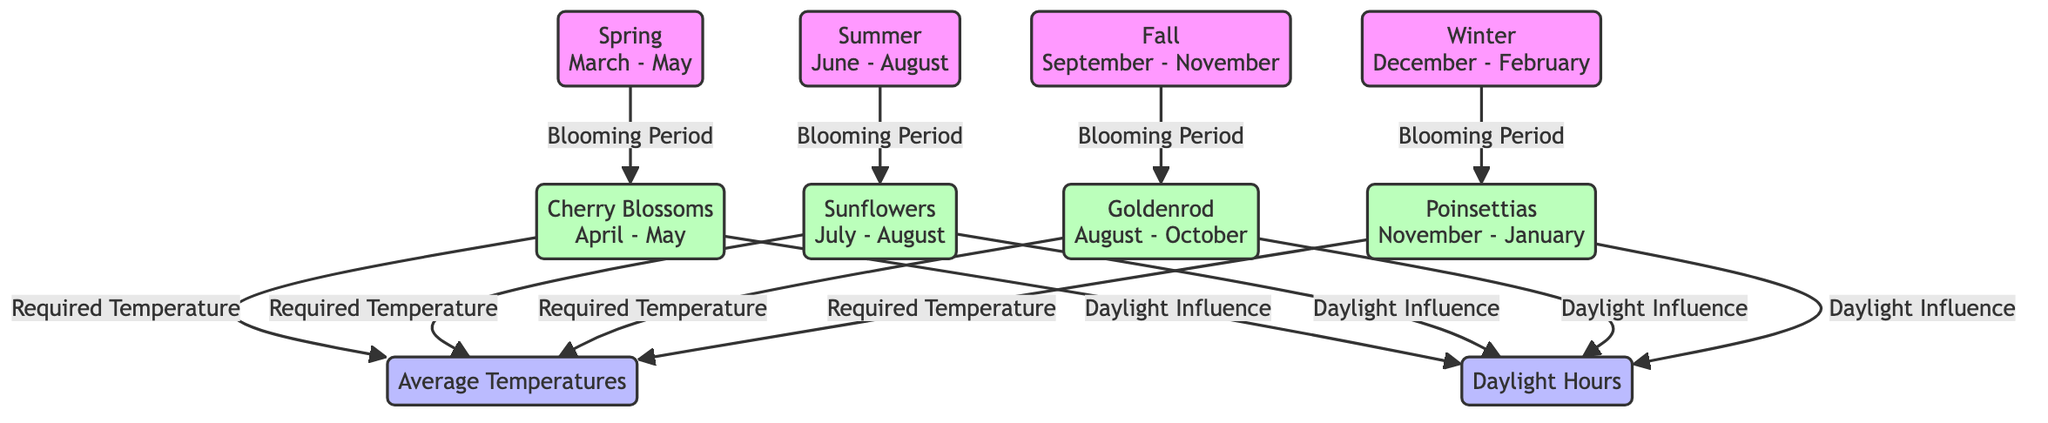What is the blooming period for Cherry Blossoms? The diagram indicates that Cherry Blossoms bloom during the months of April and May, directly connected to the spring season.
Answer: April - May Which plant blooms in the summer? According to the diagram, Sunflowers are the only plant that blooms during the summer season, which extends from June to August.
Answer: Sunflowers How many plants are shown in the diagram? The diagram features a total of four plants: Cherry Blossoms, Sunflowers, Goldenrod, and Poinsettias.
Answer: Four What season do Poinsettias bloom? Referring to the diagram, Poinsettias bloom during the winter season, which spans from December to February.
Answer: Winter Which factor influences the blooming of all plants? The diagram reveals that both Average Temperatures and Daylight Hours influence the blooming of all indicated plants. However, focusing on the required conditions, we see that temperature is specifically mentioned for every plant.
Answer: Temperature What is the daylight influence on Cherry Blossoms? The diagram clearly indicates that Daylight Hours affect the blooming of Cherry Blossoms, linking the two directly.
Answer: Daylight Hours In which months do Goldenrods bloom? According to the diagram, Goldenrods bloom from August to October, as indicated under the fall season.
Answer: August - October Which two factors are connected to all plants? By reviewing the connections within the diagram, it is evident that both Average Temperatures and Daylight Hours are factors connected to all plants regarding their blooming cycles.
Answer: Average Temperatures, Daylight Hours What is the required temperature for the blooming of Sunflowers? The diagram does not specify exact temperature values but indicates that Sunflowers require Average Temperatures, which is a common need for all plants in the diagram.
Answer: Average Temperatures 